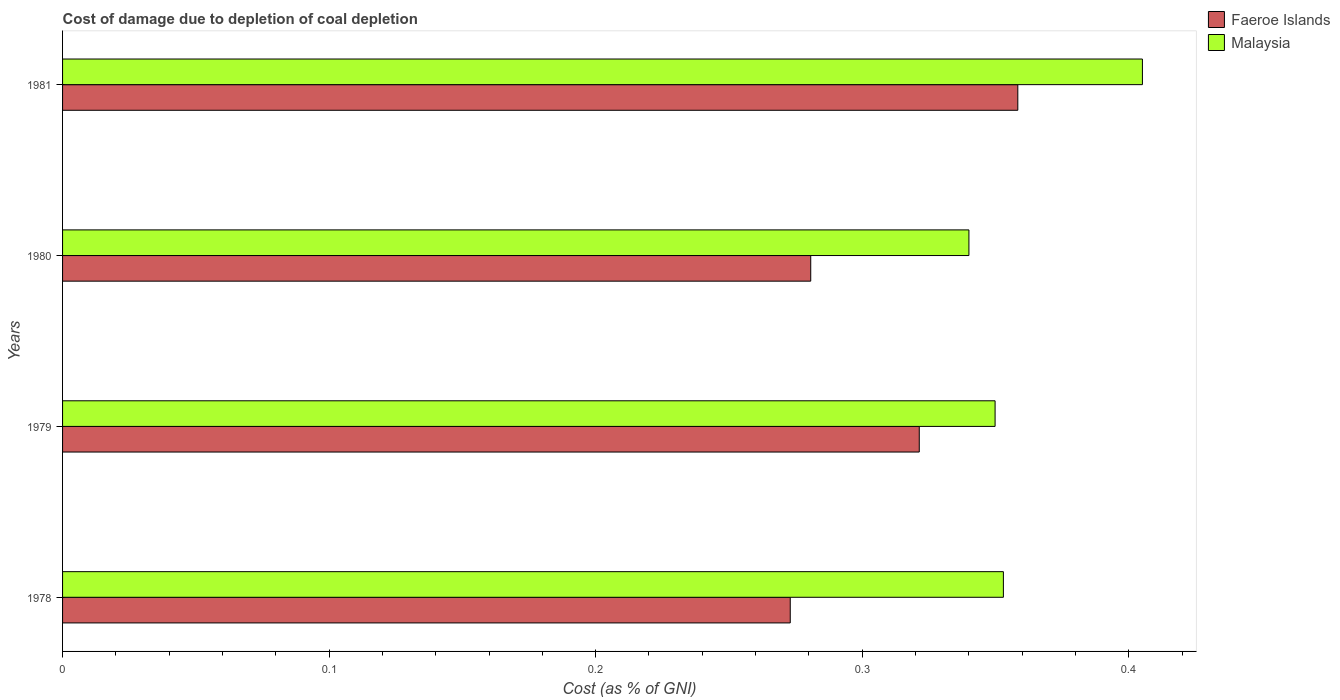How many different coloured bars are there?
Your response must be concise. 2. Are the number of bars on each tick of the Y-axis equal?
Offer a very short reply. Yes. What is the label of the 2nd group of bars from the top?
Make the answer very short. 1980. What is the cost of damage caused due to coal depletion in Malaysia in 1981?
Give a very brief answer. 0.41. Across all years, what is the maximum cost of damage caused due to coal depletion in Faeroe Islands?
Keep it short and to the point. 0.36. Across all years, what is the minimum cost of damage caused due to coal depletion in Faeroe Islands?
Your response must be concise. 0.27. In which year was the cost of damage caused due to coal depletion in Faeroe Islands maximum?
Make the answer very short. 1981. In which year was the cost of damage caused due to coal depletion in Malaysia minimum?
Your answer should be very brief. 1980. What is the total cost of damage caused due to coal depletion in Malaysia in the graph?
Provide a short and direct response. 1.45. What is the difference between the cost of damage caused due to coal depletion in Faeroe Islands in 1979 and that in 1980?
Your answer should be compact. 0.04. What is the difference between the cost of damage caused due to coal depletion in Malaysia in 1979 and the cost of damage caused due to coal depletion in Faeroe Islands in 1978?
Make the answer very short. 0.08. What is the average cost of damage caused due to coal depletion in Faeroe Islands per year?
Your answer should be very brief. 0.31. In the year 1980, what is the difference between the cost of damage caused due to coal depletion in Faeroe Islands and cost of damage caused due to coal depletion in Malaysia?
Your response must be concise. -0.06. In how many years, is the cost of damage caused due to coal depletion in Faeroe Islands greater than 0.08 %?
Provide a succinct answer. 4. What is the ratio of the cost of damage caused due to coal depletion in Faeroe Islands in 1979 to that in 1980?
Your answer should be very brief. 1.15. Is the difference between the cost of damage caused due to coal depletion in Faeroe Islands in 1978 and 1981 greater than the difference between the cost of damage caused due to coal depletion in Malaysia in 1978 and 1981?
Your response must be concise. No. What is the difference between the highest and the second highest cost of damage caused due to coal depletion in Faeroe Islands?
Offer a terse response. 0.04. What is the difference between the highest and the lowest cost of damage caused due to coal depletion in Faeroe Islands?
Offer a very short reply. 0.09. Is the sum of the cost of damage caused due to coal depletion in Faeroe Islands in 1978 and 1979 greater than the maximum cost of damage caused due to coal depletion in Malaysia across all years?
Give a very brief answer. Yes. What does the 2nd bar from the top in 1980 represents?
Provide a succinct answer. Faeroe Islands. What does the 1st bar from the bottom in 1980 represents?
Ensure brevity in your answer.  Faeroe Islands. Are all the bars in the graph horizontal?
Offer a very short reply. Yes. How many years are there in the graph?
Provide a succinct answer. 4. Are the values on the major ticks of X-axis written in scientific E-notation?
Your response must be concise. No. Where does the legend appear in the graph?
Your answer should be compact. Top right. How many legend labels are there?
Make the answer very short. 2. How are the legend labels stacked?
Offer a very short reply. Vertical. What is the title of the graph?
Your answer should be very brief. Cost of damage due to depletion of coal depletion. What is the label or title of the X-axis?
Keep it short and to the point. Cost (as % of GNI). What is the label or title of the Y-axis?
Ensure brevity in your answer.  Years. What is the Cost (as % of GNI) in Faeroe Islands in 1978?
Your answer should be very brief. 0.27. What is the Cost (as % of GNI) of Malaysia in 1978?
Your response must be concise. 0.35. What is the Cost (as % of GNI) of Faeroe Islands in 1979?
Keep it short and to the point. 0.32. What is the Cost (as % of GNI) in Malaysia in 1979?
Keep it short and to the point. 0.35. What is the Cost (as % of GNI) in Faeroe Islands in 1980?
Your response must be concise. 0.28. What is the Cost (as % of GNI) of Malaysia in 1980?
Provide a succinct answer. 0.34. What is the Cost (as % of GNI) in Faeroe Islands in 1981?
Offer a terse response. 0.36. What is the Cost (as % of GNI) of Malaysia in 1981?
Make the answer very short. 0.41. Across all years, what is the maximum Cost (as % of GNI) of Faeroe Islands?
Provide a succinct answer. 0.36. Across all years, what is the maximum Cost (as % of GNI) of Malaysia?
Give a very brief answer. 0.41. Across all years, what is the minimum Cost (as % of GNI) in Faeroe Islands?
Your response must be concise. 0.27. Across all years, what is the minimum Cost (as % of GNI) of Malaysia?
Your answer should be compact. 0.34. What is the total Cost (as % of GNI) of Faeroe Islands in the graph?
Provide a succinct answer. 1.23. What is the total Cost (as % of GNI) of Malaysia in the graph?
Provide a short and direct response. 1.45. What is the difference between the Cost (as % of GNI) of Faeroe Islands in 1978 and that in 1979?
Give a very brief answer. -0.05. What is the difference between the Cost (as % of GNI) in Malaysia in 1978 and that in 1979?
Offer a very short reply. 0. What is the difference between the Cost (as % of GNI) in Faeroe Islands in 1978 and that in 1980?
Provide a short and direct response. -0.01. What is the difference between the Cost (as % of GNI) in Malaysia in 1978 and that in 1980?
Ensure brevity in your answer.  0.01. What is the difference between the Cost (as % of GNI) in Faeroe Islands in 1978 and that in 1981?
Your response must be concise. -0.09. What is the difference between the Cost (as % of GNI) in Malaysia in 1978 and that in 1981?
Offer a very short reply. -0.05. What is the difference between the Cost (as % of GNI) in Faeroe Islands in 1979 and that in 1980?
Your response must be concise. 0.04. What is the difference between the Cost (as % of GNI) of Malaysia in 1979 and that in 1980?
Provide a succinct answer. 0.01. What is the difference between the Cost (as % of GNI) in Faeroe Islands in 1979 and that in 1981?
Offer a terse response. -0.04. What is the difference between the Cost (as % of GNI) in Malaysia in 1979 and that in 1981?
Keep it short and to the point. -0.06. What is the difference between the Cost (as % of GNI) in Faeroe Islands in 1980 and that in 1981?
Give a very brief answer. -0.08. What is the difference between the Cost (as % of GNI) in Malaysia in 1980 and that in 1981?
Offer a very short reply. -0.07. What is the difference between the Cost (as % of GNI) of Faeroe Islands in 1978 and the Cost (as % of GNI) of Malaysia in 1979?
Make the answer very short. -0.08. What is the difference between the Cost (as % of GNI) in Faeroe Islands in 1978 and the Cost (as % of GNI) in Malaysia in 1980?
Ensure brevity in your answer.  -0.07. What is the difference between the Cost (as % of GNI) of Faeroe Islands in 1978 and the Cost (as % of GNI) of Malaysia in 1981?
Make the answer very short. -0.13. What is the difference between the Cost (as % of GNI) of Faeroe Islands in 1979 and the Cost (as % of GNI) of Malaysia in 1980?
Keep it short and to the point. -0.02. What is the difference between the Cost (as % of GNI) in Faeroe Islands in 1979 and the Cost (as % of GNI) in Malaysia in 1981?
Provide a succinct answer. -0.08. What is the difference between the Cost (as % of GNI) in Faeroe Islands in 1980 and the Cost (as % of GNI) in Malaysia in 1981?
Provide a short and direct response. -0.12. What is the average Cost (as % of GNI) of Faeroe Islands per year?
Offer a very short reply. 0.31. What is the average Cost (as % of GNI) in Malaysia per year?
Make the answer very short. 0.36. In the year 1978, what is the difference between the Cost (as % of GNI) in Faeroe Islands and Cost (as % of GNI) in Malaysia?
Your answer should be very brief. -0.08. In the year 1979, what is the difference between the Cost (as % of GNI) in Faeroe Islands and Cost (as % of GNI) in Malaysia?
Your response must be concise. -0.03. In the year 1980, what is the difference between the Cost (as % of GNI) in Faeroe Islands and Cost (as % of GNI) in Malaysia?
Provide a succinct answer. -0.06. In the year 1981, what is the difference between the Cost (as % of GNI) of Faeroe Islands and Cost (as % of GNI) of Malaysia?
Ensure brevity in your answer.  -0.05. What is the ratio of the Cost (as % of GNI) in Faeroe Islands in 1978 to that in 1979?
Your response must be concise. 0.85. What is the ratio of the Cost (as % of GNI) in Malaysia in 1978 to that in 1979?
Ensure brevity in your answer.  1.01. What is the ratio of the Cost (as % of GNI) in Faeroe Islands in 1978 to that in 1980?
Your response must be concise. 0.97. What is the ratio of the Cost (as % of GNI) of Malaysia in 1978 to that in 1980?
Provide a short and direct response. 1.04. What is the ratio of the Cost (as % of GNI) in Faeroe Islands in 1978 to that in 1981?
Give a very brief answer. 0.76. What is the ratio of the Cost (as % of GNI) in Malaysia in 1978 to that in 1981?
Your response must be concise. 0.87. What is the ratio of the Cost (as % of GNI) in Faeroe Islands in 1979 to that in 1980?
Your response must be concise. 1.15. What is the ratio of the Cost (as % of GNI) in Malaysia in 1979 to that in 1980?
Ensure brevity in your answer.  1.03. What is the ratio of the Cost (as % of GNI) in Faeroe Islands in 1979 to that in 1981?
Offer a very short reply. 0.9. What is the ratio of the Cost (as % of GNI) in Malaysia in 1979 to that in 1981?
Your answer should be very brief. 0.86. What is the ratio of the Cost (as % of GNI) in Faeroe Islands in 1980 to that in 1981?
Your answer should be very brief. 0.78. What is the ratio of the Cost (as % of GNI) of Malaysia in 1980 to that in 1981?
Keep it short and to the point. 0.84. What is the difference between the highest and the second highest Cost (as % of GNI) of Faeroe Islands?
Offer a very short reply. 0.04. What is the difference between the highest and the second highest Cost (as % of GNI) in Malaysia?
Your answer should be compact. 0.05. What is the difference between the highest and the lowest Cost (as % of GNI) of Faeroe Islands?
Keep it short and to the point. 0.09. What is the difference between the highest and the lowest Cost (as % of GNI) of Malaysia?
Ensure brevity in your answer.  0.07. 